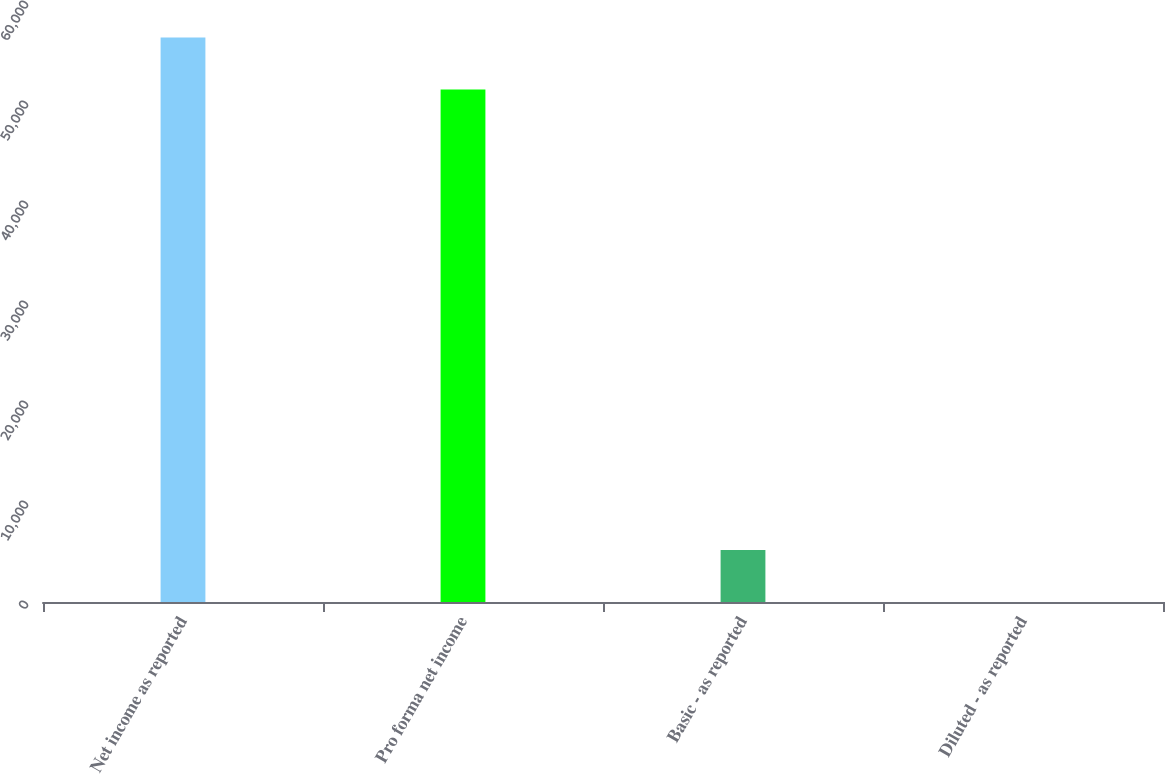Convert chart. <chart><loc_0><loc_0><loc_500><loc_500><bar_chart><fcel>Net income as reported<fcel>Pro forma net income<fcel>Basic - as reported<fcel>Diluted - as reported<nl><fcel>56459.4<fcel>51254<fcel>5206.17<fcel>0.74<nl></chart> 